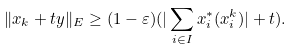Convert formula to latex. <formula><loc_0><loc_0><loc_500><loc_500>\| x _ { k } + t y \| _ { E } \geq ( 1 - \varepsilon ) ( | \sum _ { i \in I } x ^ { \ast } _ { i } ( x ^ { k } _ { i } ) | + t ) .</formula> 